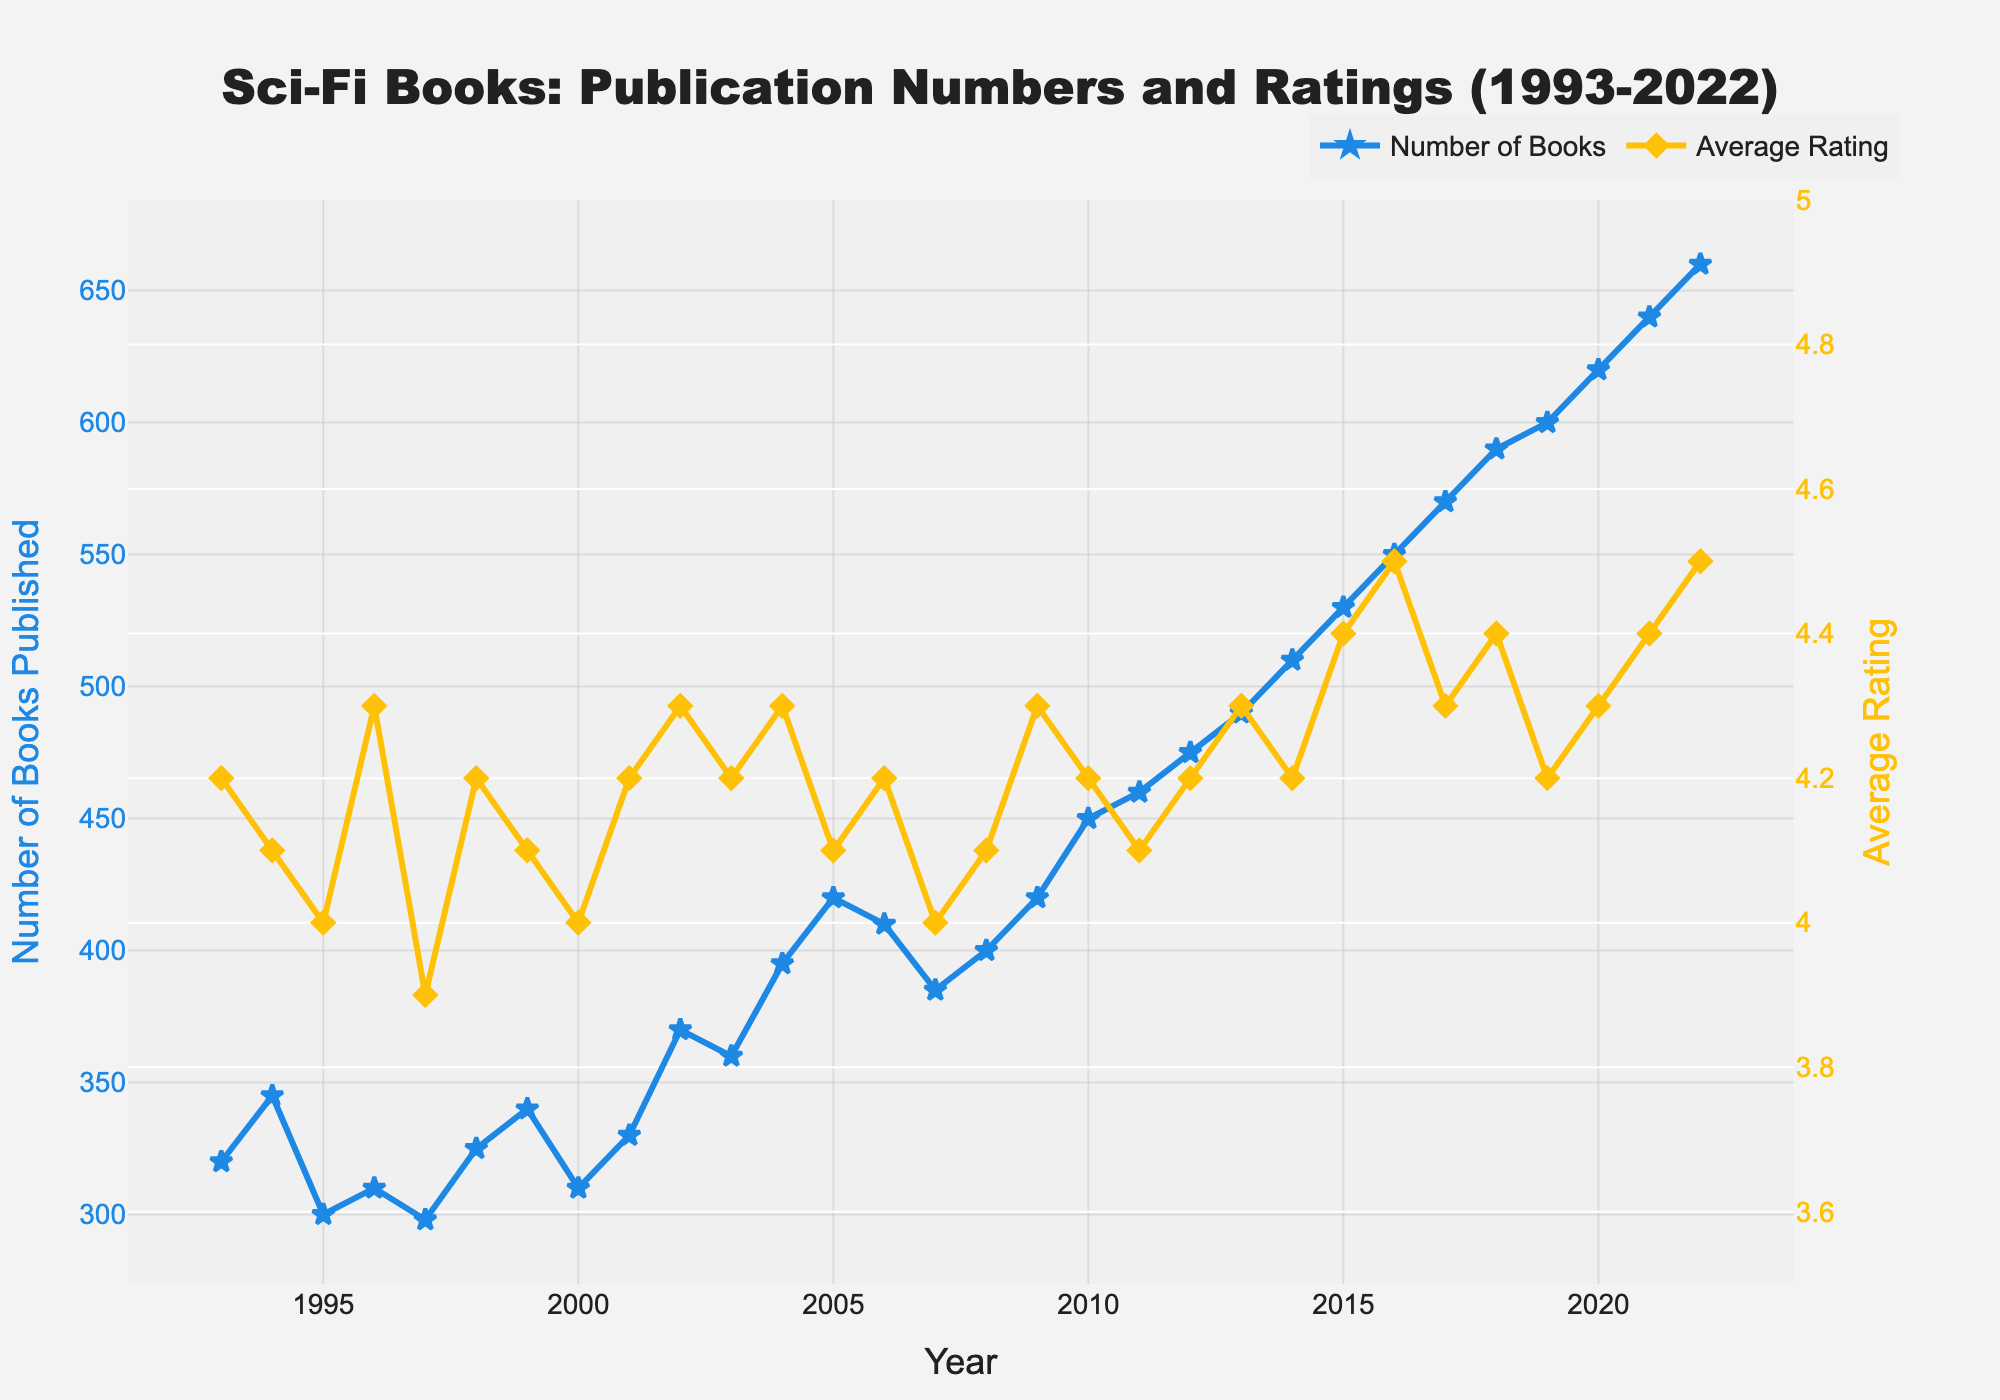What is the color of the lines representing the average rating in the plot? The average rating line is colored yellow. This can be determined by observing the line and the corresponding legend on the plot.
Answer: Yellow What is the title of the plot? The title of the plot is displayed at the top and reads "Sci-Fi Books: Publication Numbers and Ratings (1993-2022)".
Answer: Sci-Fi Books: Publication Numbers and Ratings (1993-2022) How many sci-fi books were published in the year 2010? Locate the year 2010 on the x-axis and follow the vertical line to the intersection with the blue line representing the number of books. The value can be read off the left y-axis.
Answer: 450 How did the average rating of sci-fi books change between 2015 and 2016? Identify the data points for 2015 and 2016 on the yellow line representing average ratings. Compare the two values indicated by the yellow data points and read off the right y-axis.
Answer: Increased from 4.4 to 4.5 Which year saw the highest number of sci-fi books published? Look for the highest peak in the blue line representing the number of books published and match it to the corresponding year on the x-axis.
Answer: 2022 How many more sci-fi books were published in 2022 compared to 1993? Find the number of books published in 1993 and 2022 on the blue line and subtract the former from the latter. According to the plot, 660 books were published in 2022, and 320 in 1993. The difference is 660 - 320.
Answer: 340 What trend do you observe in the number of sci-fi books published from 1993 to 2022? Observe the blue line representing the number of books published over the years. The trend shows a general increase in the number of books published from 1993 to 2022, with several fluctuations.
Answer: Increasing trend Between which two consecutive years did the average rating of sci-fi books decrease? Observe the yellow line representing the average ratings. Look for sections where the line slopes downward and identify the corresponding years on the x-axis. The decrease occurs between 2010 and 2011.
Answer: 2010 and 2011 What is the highest average rating recorded in the dataset, and in which year(s) was it observed? Find the peak value on the yellow line representing average ratings. The highest value is 4.5, observed in 2016 and again in 2022.
Answer: 4.5 in 2016 and 2022 What can you say about the correlation between the number of sci-fi books published and their average ratings from 1993 to 2022? Analyze the correlation by observing the general relationship between the blue and yellow lines. While the number of books published shows a clear increasing trend, the average ratings exhibit less consistent changes with occasional increases and decreases. This suggests a weak or no direct correlation between the two variables.
Answer: Weak or no direct correlation 